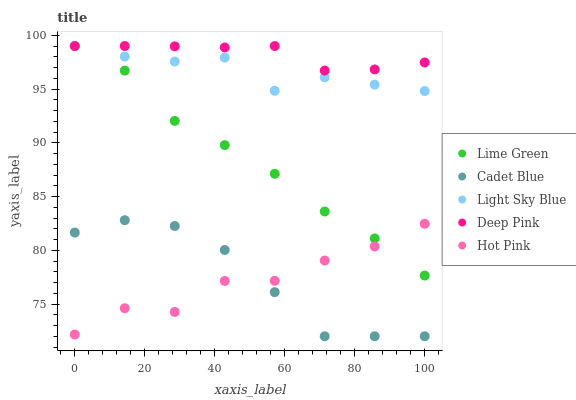Does Hot Pink have the minimum area under the curve?
Answer yes or no. Yes. Does Deep Pink have the maximum area under the curve?
Answer yes or no. Yes. Does Cadet Blue have the minimum area under the curve?
Answer yes or no. No. Does Cadet Blue have the maximum area under the curve?
Answer yes or no. No. Is Deep Pink the smoothest?
Answer yes or no. Yes. Is Hot Pink the roughest?
Answer yes or no. Yes. Is Cadet Blue the smoothest?
Answer yes or no. No. Is Cadet Blue the roughest?
Answer yes or no. No. Does Cadet Blue have the lowest value?
Answer yes or no. Yes. Does Lime Green have the lowest value?
Answer yes or no. No. Does Deep Pink have the highest value?
Answer yes or no. Yes. Does Cadet Blue have the highest value?
Answer yes or no. No. Is Hot Pink less than Light Sky Blue?
Answer yes or no. Yes. Is Light Sky Blue greater than Hot Pink?
Answer yes or no. Yes. Does Light Sky Blue intersect Lime Green?
Answer yes or no. Yes. Is Light Sky Blue less than Lime Green?
Answer yes or no. No. Is Light Sky Blue greater than Lime Green?
Answer yes or no. No. Does Hot Pink intersect Light Sky Blue?
Answer yes or no. No. 